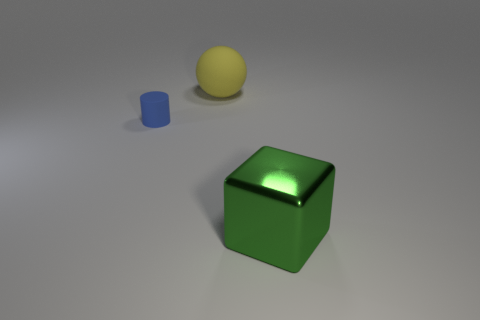What is the material of the yellow ball that is the same size as the green cube?
Your response must be concise. Rubber. How many other things are made of the same material as the ball?
Give a very brief answer. 1. There is a green cube; is it the same size as the object behind the blue matte cylinder?
Keep it short and to the point. Yes. What color is the shiny cube?
Make the answer very short. Green. The matte object that is behind the matte thing that is in front of the large object that is behind the large metallic object is what shape?
Keep it short and to the point. Sphere. There is a big green cube that is to the right of the large object behind the small blue matte cylinder; what is its material?
Offer a very short reply. Metal. There is another large thing that is made of the same material as the blue object; what shape is it?
Your answer should be compact. Sphere. Are there any other things that have the same shape as the big yellow object?
Keep it short and to the point. No. There is a large yellow thing; what number of yellow matte balls are to the left of it?
Your answer should be compact. 0. Are there any big yellow blocks?
Provide a succinct answer. No. 